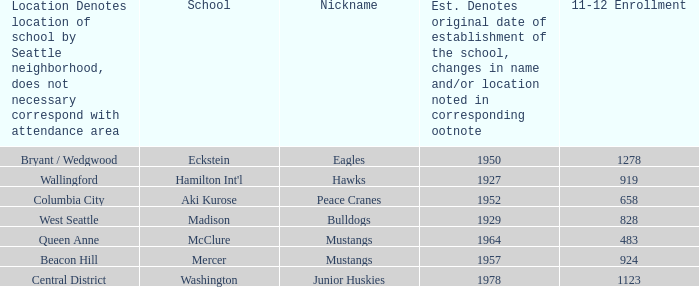Name the school for columbia city Aki Kurose. 